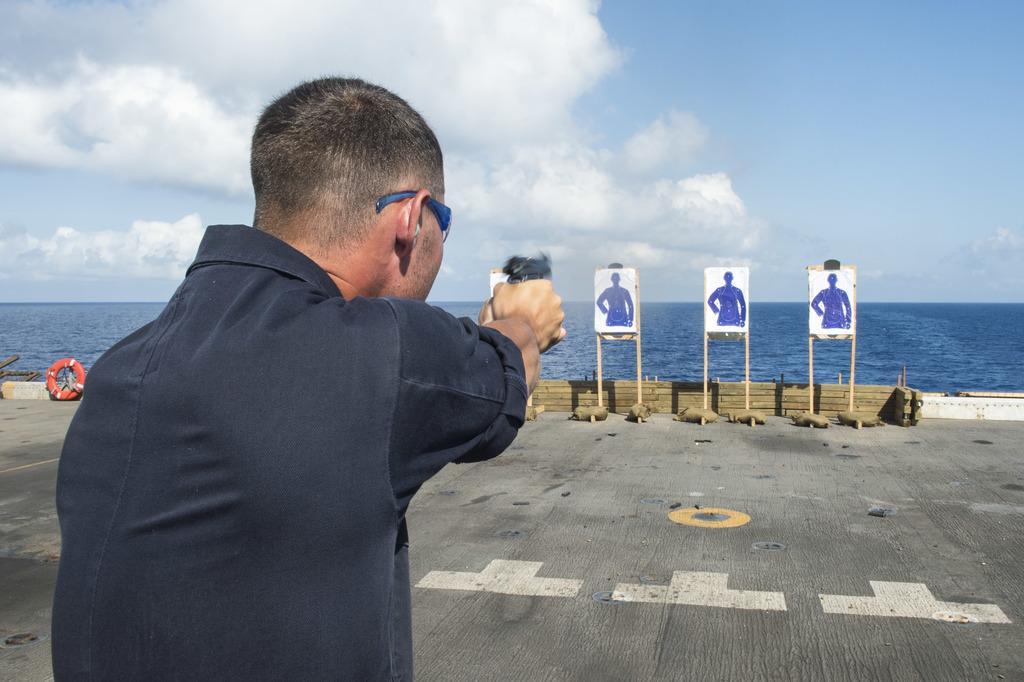Could you give a brief overview of what you see in this image? In this image on the left, there is a man, he wears a shirt, he is holding a gun. At the bottom there is floor. In the middle there are posters, boards. In the background there are waves, water, sky and clouds. 